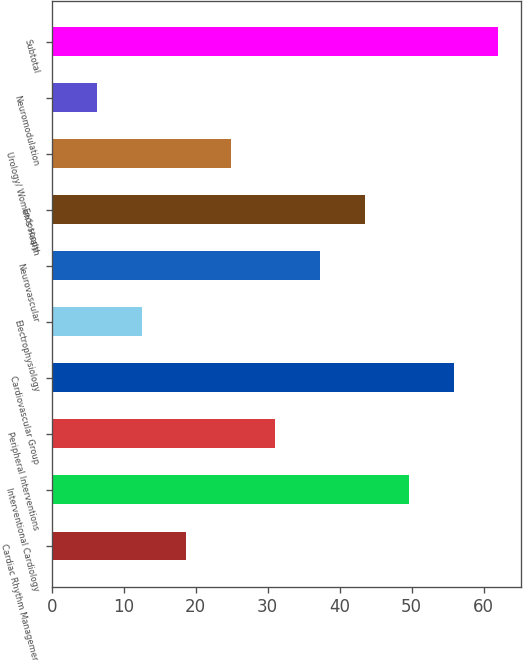<chart> <loc_0><loc_0><loc_500><loc_500><bar_chart><fcel>Cardiac Rhythm Management<fcel>Interventional Cardiology<fcel>Peripheral Interventions<fcel>Cardiovascular Group<fcel>Electrophysiology<fcel>Neurovascular<fcel>Endoscopy<fcel>Urology/ Women's Health<fcel>Neuromodulation<fcel>Subtotal<nl><fcel>18.69<fcel>49.64<fcel>31.07<fcel>55.83<fcel>12.5<fcel>37.26<fcel>43.45<fcel>24.88<fcel>6.31<fcel>62.02<nl></chart> 